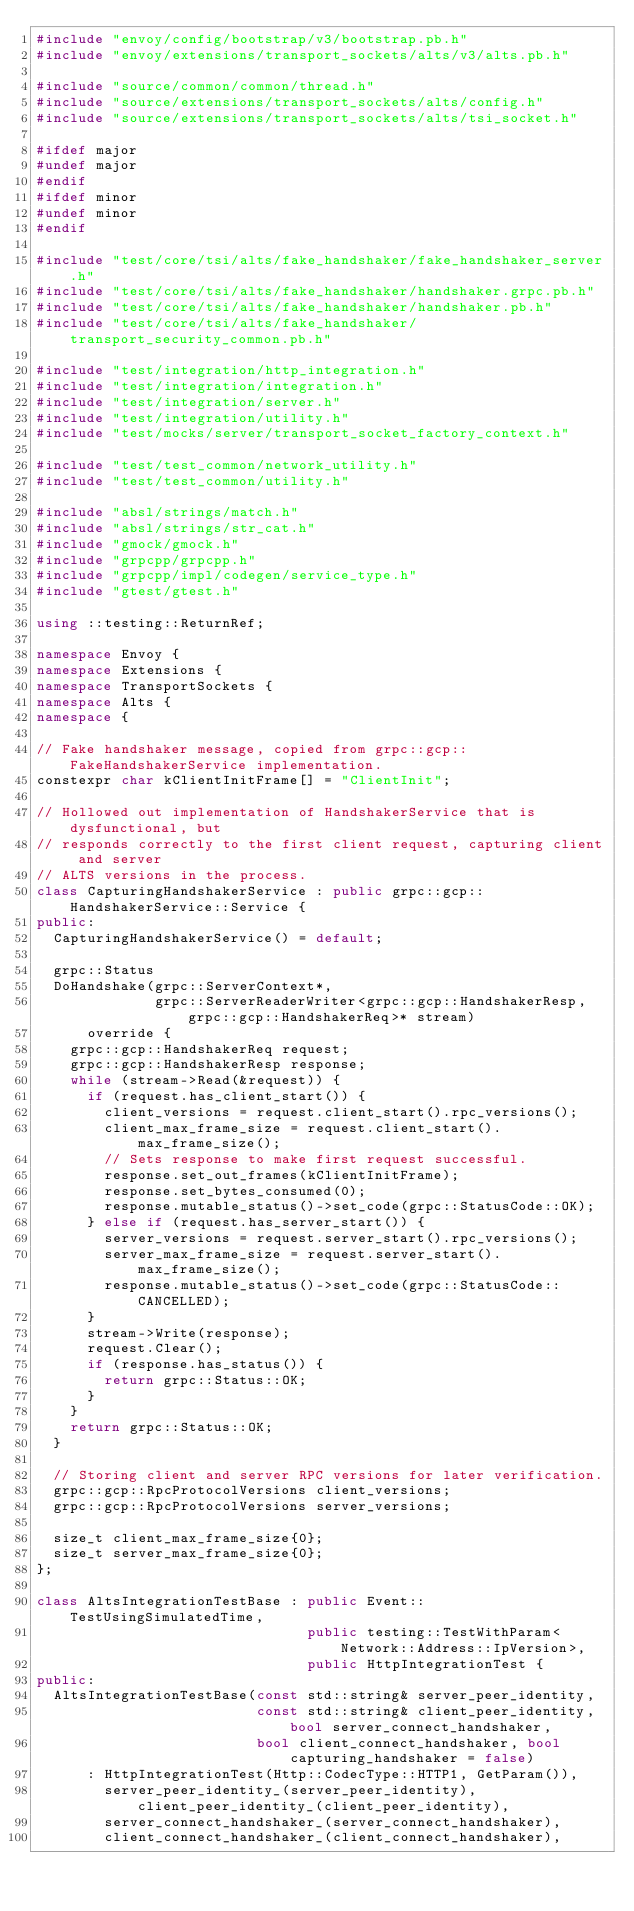Convert code to text. <code><loc_0><loc_0><loc_500><loc_500><_C++_>#include "envoy/config/bootstrap/v3/bootstrap.pb.h"
#include "envoy/extensions/transport_sockets/alts/v3/alts.pb.h"

#include "source/common/common/thread.h"
#include "source/extensions/transport_sockets/alts/config.h"
#include "source/extensions/transport_sockets/alts/tsi_socket.h"

#ifdef major
#undef major
#endif
#ifdef minor
#undef minor
#endif

#include "test/core/tsi/alts/fake_handshaker/fake_handshaker_server.h"
#include "test/core/tsi/alts/fake_handshaker/handshaker.grpc.pb.h"
#include "test/core/tsi/alts/fake_handshaker/handshaker.pb.h"
#include "test/core/tsi/alts/fake_handshaker/transport_security_common.pb.h"

#include "test/integration/http_integration.h"
#include "test/integration/integration.h"
#include "test/integration/server.h"
#include "test/integration/utility.h"
#include "test/mocks/server/transport_socket_factory_context.h"

#include "test/test_common/network_utility.h"
#include "test/test_common/utility.h"

#include "absl/strings/match.h"
#include "absl/strings/str_cat.h"
#include "gmock/gmock.h"
#include "grpcpp/grpcpp.h"
#include "grpcpp/impl/codegen/service_type.h"
#include "gtest/gtest.h"

using ::testing::ReturnRef;

namespace Envoy {
namespace Extensions {
namespace TransportSockets {
namespace Alts {
namespace {

// Fake handshaker message, copied from grpc::gcp::FakeHandshakerService implementation.
constexpr char kClientInitFrame[] = "ClientInit";

// Hollowed out implementation of HandshakerService that is dysfunctional, but
// responds correctly to the first client request, capturing client and server
// ALTS versions in the process.
class CapturingHandshakerService : public grpc::gcp::HandshakerService::Service {
public:
  CapturingHandshakerService() = default;

  grpc::Status
  DoHandshake(grpc::ServerContext*,
              grpc::ServerReaderWriter<grpc::gcp::HandshakerResp, grpc::gcp::HandshakerReq>* stream)
      override {
    grpc::gcp::HandshakerReq request;
    grpc::gcp::HandshakerResp response;
    while (stream->Read(&request)) {
      if (request.has_client_start()) {
        client_versions = request.client_start().rpc_versions();
        client_max_frame_size = request.client_start().max_frame_size();
        // Sets response to make first request successful.
        response.set_out_frames(kClientInitFrame);
        response.set_bytes_consumed(0);
        response.mutable_status()->set_code(grpc::StatusCode::OK);
      } else if (request.has_server_start()) {
        server_versions = request.server_start().rpc_versions();
        server_max_frame_size = request.server_start().max_frame_size();
        response.mutable_status()->set_code(grpc::StatusCode::CANCELLED);
      }
      stream->Write(response);
      request.Clear();
      if (response.has_status()) {
        return grpc::Status::OK;
      }
    }
    return grpc::Status::OK;
  }

  // Storing client and server RPC versions for later verification.
  grpc::gcp::RpcProtocolVersions client_versions;
  grpc::gcp::RpcProtocolVersions server_versions;

  size_t client_max_frame_size{0};
  size_t server_max_frame_size{0};
};

class AltsIntegrationTestBase : public Event::TestUsingSimulatedTime,
                                public testing::TestWithParam<Network::Address::IpVersion>,
                                public HttpIntegrationTest {
public:
  AltsIntegrationTestBase(const std::string& server_peer_identity,
                          const std::string& client_peer_identity, bool server_connect_handshaker,
                          bool client_connect_handshaker, bool capturing_handshaker = false)
      : HttpIntegrationTest(Http::CodecType::HTTP1, GetParam()),
        server_peer_identity_(server_peer_identity), client_peer_identity_(client_peer_identity),
        server_connect_handshaker_(server_connect_handshaker),
        client_connect_handshaker_(client_connect_handshaker),</code> 